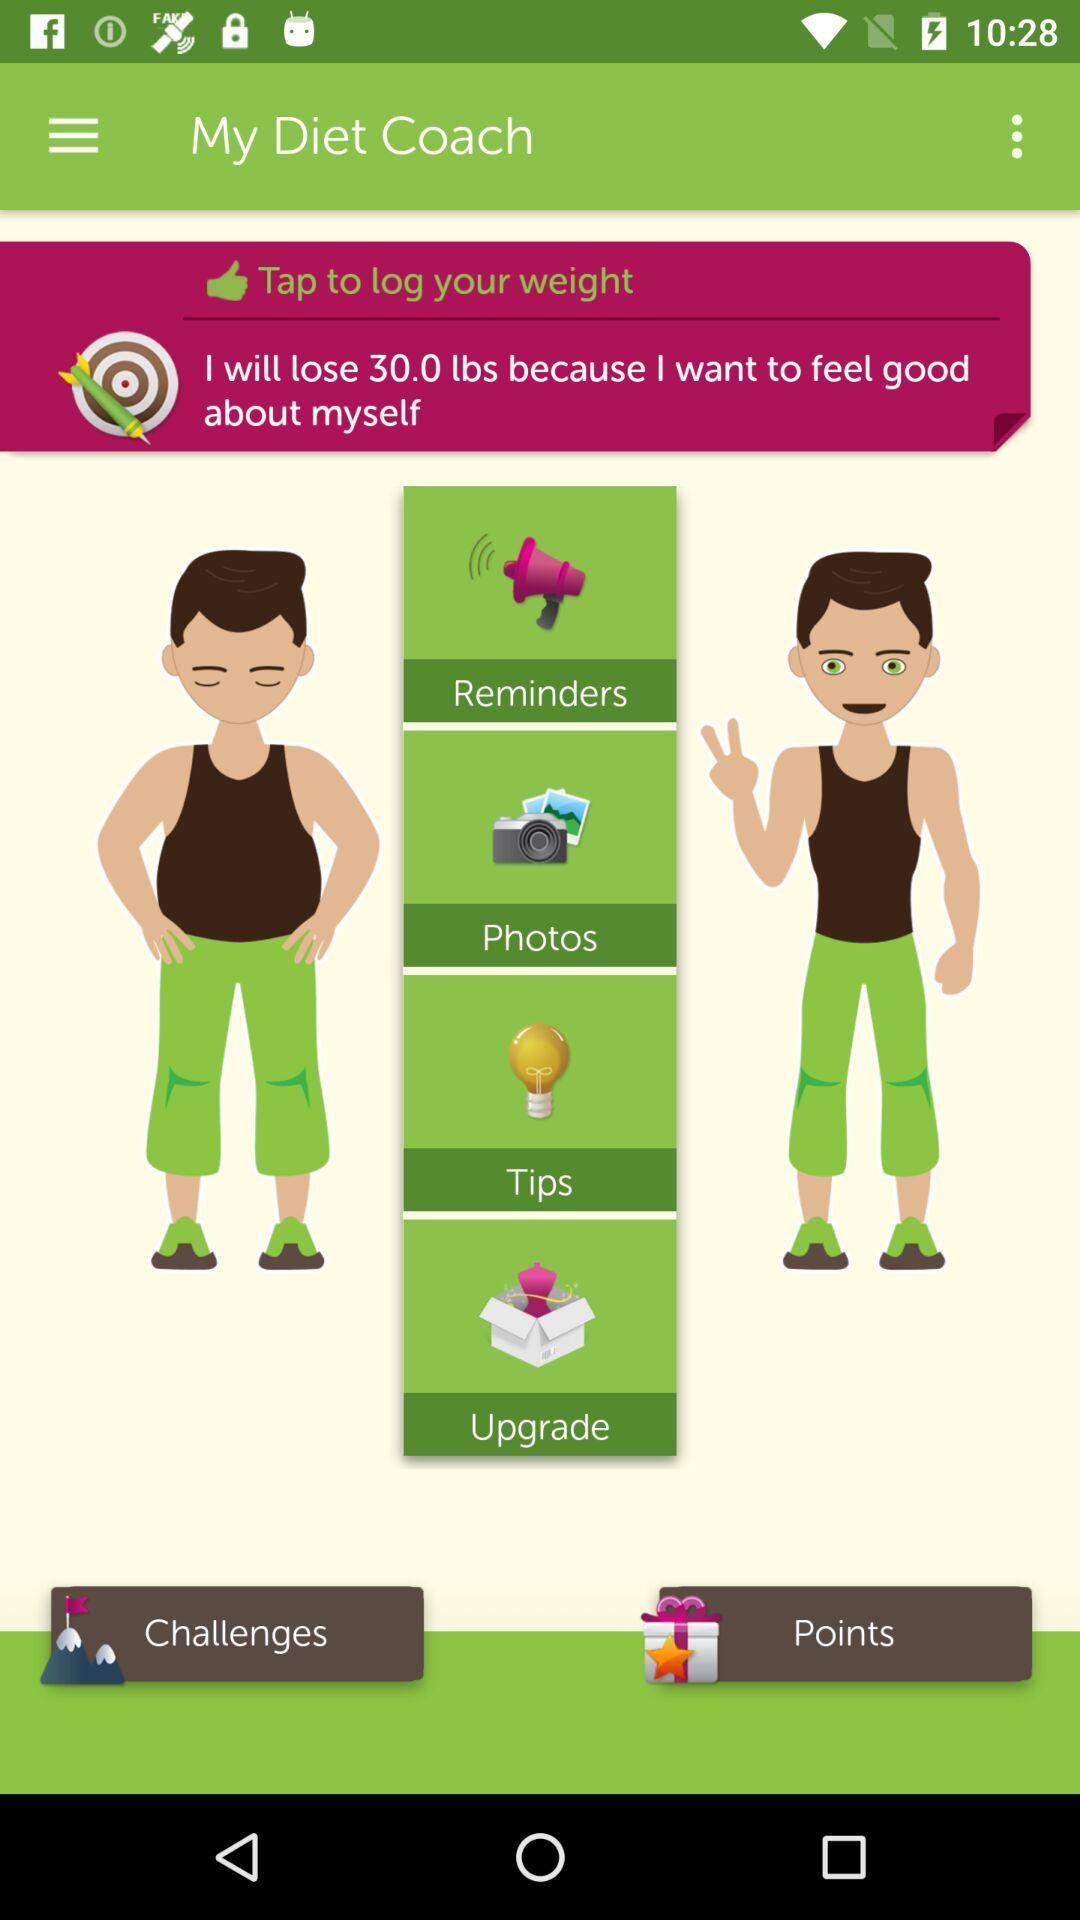How many pounds must we shed in order to feel good? You must shed 30.0 lbs in order to feel good. 